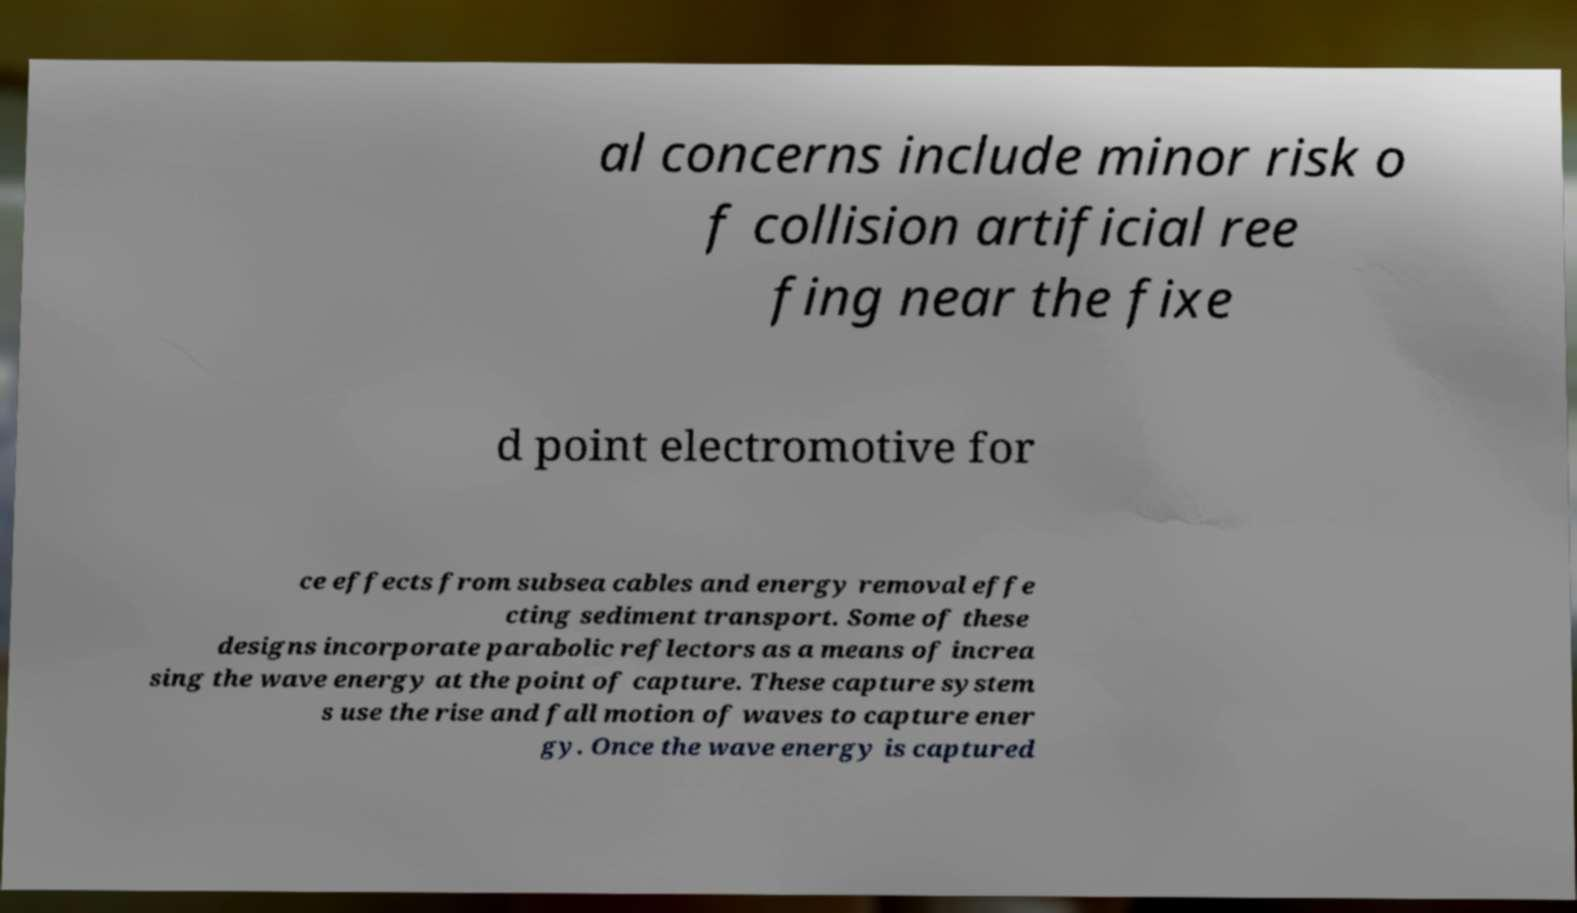Can you read and provide the text displayed in the image?This photo seems to have some interesting text. Can you extract and type it out for me? al concerns include minor risk o f collision artificial ree fing near the fixe d point electromotive for ce effects from subsea cables and energy removal effe cting sediment transport. Some of these designs incorporate parabolic reflectors as a means of increa sing the wave energy at the point of capture. These capture system s use the rise and fall motion of waves to capture ener gy. Once the wave energy is captured 